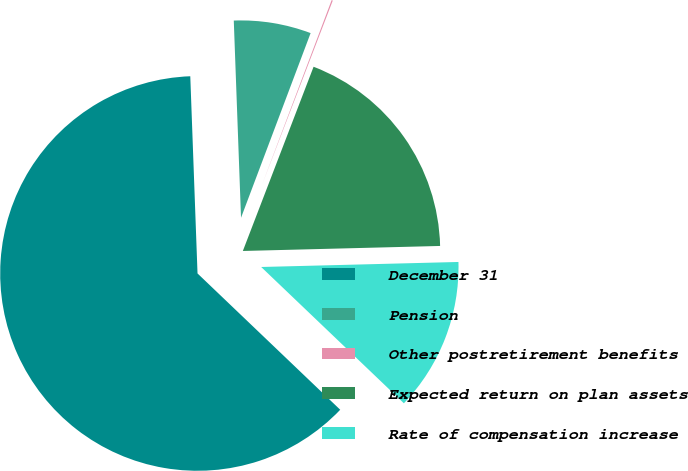Convert chart. <chart><loc_0><loc_0><loc_500><loc_500><pie_chart><fcel>December 31<fcel>Pension<fcel>Other postretirement benefits<fcel>Expected return on plan assets<fcel>Rate of compensation increase<nl><fcel>62.28%<fcel>6.32%<fcel>0.1%<fcel>18.76%<fcel>12.54%<nl></chart> 